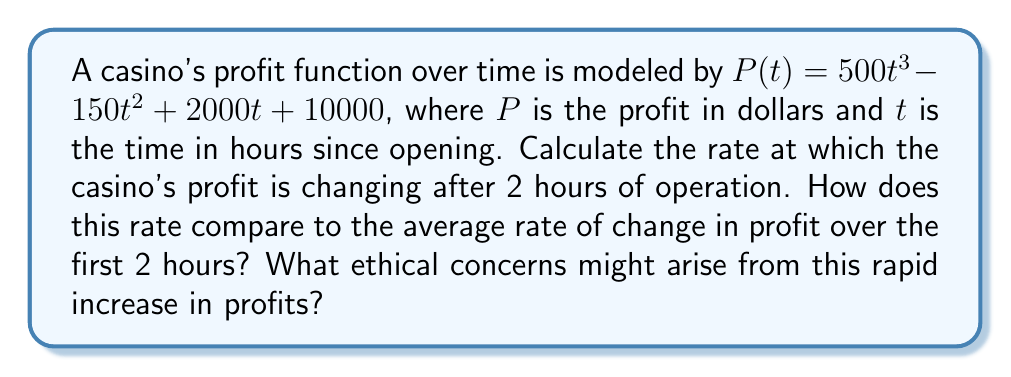Teach me how to tackle this problem. 1) To find the rate of change at t = 2 hours, we need to calculate the derivative of P(t) and evaluate it at t = 2.

   $$P'(t) = 1500t^2 - 300t + 2000$$

2) Evaluate P'(2):
   
   $$P'(2) = 1500(2)^2 - 300(2) + 2000 = 6000 - 600 + 2000 = 7400$$

3) To find the average rate of change over the first 2 hours:

   $$\text{Average rate} = \frac{P(2) - P(0)}{2 - 0}$$

4) Calculate P(2) and P(0):
   
   $$P(2) = 500(2)^3 - 150(2)^2 + 2000(2) + 10000 = 4000 - 600 + 4000 + 10000 = 17400$$
   $$P(0) = 10000$$

5) Now, calculate the average rate:

   $$\text{Average rate} = \frac{17400 - 10000}{2} = 3700$$

6) Compare:
   Instantaneous rate at t = 2: $7400 per hour
   Average rate over first 2 hours: $3700 per hour

The instantaneous rate is twice the average rate, indicating accelerating profits.

Ethical concerns:
1) Rapid profit increase may encourage addictive behavior.
2) It suggests the odds are heavily stacked against players.
3) Such profit rates might be exploitative, especially of vulnerable individuals.
Answer: $7400 per hour; twice the average rate; raises ethical concerns about exploitation and addiction. 